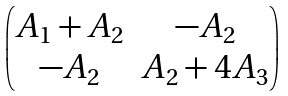<formula> <loc_0><loc_0><loc_500><loc_500>\begin{pmatrix} A _ { 1 } + A _ { 2 } & - A _ { 2 } \\ - A _ { 2 } & A _ { 2 } + 4 A _ { 3 } \end{pmatrix}</formula> 